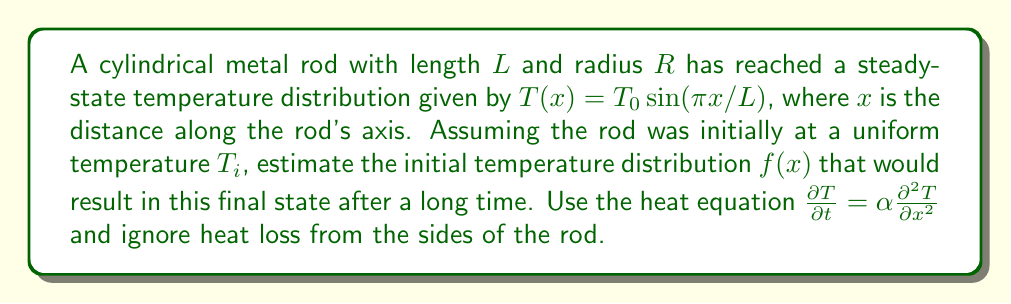What is the answer to this math problem? 1) The steady-state solution satisfies the heat equation with $\frac{\partial T}{\partial t} = 0$:

   $$\alpha \frac{d^2 T}{dx^2} = 0$$

2) The general solution to this is linear: $T(x) = ax + b$. However, our given solution is $T(x) = T_0 \sin(\pi x/L)$, which satisfies the boundary conditions $T(0) = T(L) = 0$.

3) To find the initial distribution $f(x)$, we can use separation of variables:

   $$T(x,t) = X(x)e^{-\lambda \alpha t}$$

4) Substituting into the heat equation:

   $$X''(x) + \lambda X(x) = 0$$

5) The general solution is:

   $$X(x) = A \sin(\sqrt{\lambda}x) + B \cos(\sqrt{\lambda}x)$$

6) To match our boundary conditions, we need $\sqrt{\lambda} = n\pi/L$, where $n$ is an integer.

7) The full solution is a sum of these modes:

   $$T(x,t) = \sum_{n=1}^{\infty} A_n \sin(n\pi x/L) e^{-n^2\pi^2\alpha t/L^2}$$

8) At $t=0$, this should equal our initial distribution $f(x)$:

   $$f(x) = \sum_{n=1}^{\infty} A_n \sin(n\pi x/L)$$

9) For large $t$, only the $n=1$ term survives, which must match our given final state:

   $$T_0 \sin(\pi x/L) = A_1 \sin(\pi x/L) e^{-\pi^2\alpha t/L^2}$$

10) Therefore, $A_1 = T_0 e^{\pi^2\alpha t/L^2}$, which grows larger as $t$ increases.

11) To minimize the initial energy, we can assume all other $A_n = 0$ for $n > 1$.

12) Thus, our estimate for the initial temperature distribution is:

    $$f(x) = T_0 e^{\pi^2\alpha t/L^2} \sin(\pi x/L)$$

    where $t$ is some large time value.
Answer: $f(x) = T_0 e^{\pi^2\alpha t/L^2} \sin(\pi x/L)$ 